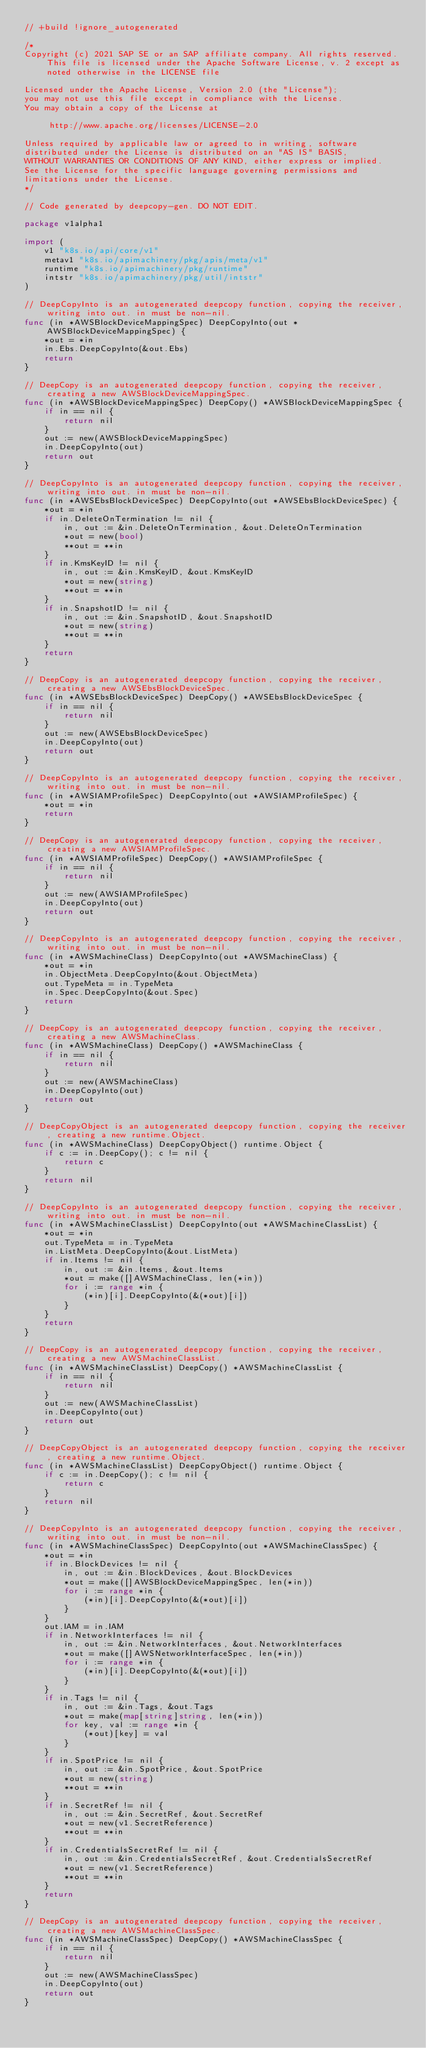<code> <loc_0><loc_0><loc_500><loc_500><_Go_>// +build !ignore_autogenerated

/*
Copyright (c) 2021 SAP SE or an SAP affiliate company. All rights reserved. This file is licensed under the Apache Software License, v. 2 except as noted otherwise in the LICENSE file

Licensed under the Apache License, Version 2.0 (the "License");
you may not use this file except in compliance with the License.
You may obtain a copy of the License at

     http://www.apache.org/licenses/LICENSE-2.0

Unless required by applicable law or agreed to in writing, software
distributed under the License is distributed on an "AS IS" BASIS,
WITHOUT WARRANTIES OR CONDITIONS OF ANY KIND, either express or implied.
See the License for the specific language governing permissions and
limitations under the License.
*/

// Code generated by deepcopy-gen. DO NOT EDIT.

package v1alpha1

import (
	v1 "k8s.io/api/core/v1"
	metav1 "k8s.io/apimachinery/pkg/apis/meta/v1"
	runtime "k8s.io/apimachinery/pkg/runtime"
	intstr "k8s.io/apimachinery/pkg/util/intstr"
)

// DeepCopyInto is an autogenerated deepcopy function, copying the receiver, writing into out. in must be non-nil.
func (in *AWSBlockDeviceMappingSpec) DeepCopyInto(out *AWSBlockDeviceMappingSpec) {
	*out = *in
	in.Ebs.DeepCopyInto(&out.Ebs)
	return
}

// DeepCopy is an autogenerated deepcopy function, copying the receiver, creating a new AWSBlockDeviceMappingSpec.
func (in *AWSBlockDeviceMappingSpec) DeepCopy() *AWSBlockDeviceMappingSpec {
	if in == nil {
		return nil
	}
	out := new(AWSBlockDeviceMappingSpec)
	in.DeepCopyInto(out)
	return out
}

// DeepCopyInto is an autogenerated deepcopy function, copying the receiver, writing into out. in must be non-nil.
func (in *AWSEbsBlockDeviceSpec) DeepCopyInto(out *AWSEbsBlockDeviceSpec) {
	*out = *in
	if in.DeleteOnTermination != nil {
		in, out := &in.DeleteOnTermination, &out.DeleteOnTermination
		*out = new(bool)
		**out = **in
	}
	if in.KmsKeyID != nil {
		in, out := &in.KmsKeyID, &out.KmsKeyID
		*out = new(string)
		**out = **in
	}
	if in.SnapshotID != nil {
		in, out := &in.SnapshotID, &out.SnapshotID
		*out = new(string)
		**out = **in
	}
	return
}

// DeepCopy is an autogenerated deepcopy function, copying the receiver, creating a new AWSEbsBlockDeviceSpec.
func (in *AWSEbsBlockDeviceSpec) DeepCopy() *AWSEbsBlockDeviceSpec {
	if in == nil {
		return nil
	}
	out := new(AWSEbsBlockDeviceSpec)
	in.DeepCopyInto(out)
	return out
}

// DeepCopyInto is an autogenerated deepcopy function, copying the receiver, writing into out. in must be non-nil.
func (in *AWSIAMProfileSpec) DeepCopyInto(out *AWSIAMProfileSpec) {
	*out = *in
	return
}

// DeepCopy is an autogenerated deepcopy function, copying the receiver, creating a new AWSIAMProfileSpec.
func (in *AWSIAMProfileSpec) DeepCopy() *AWSIAMProfileSpec {
	if in == nil {
		return nil
	}
	out := new(AWSIAMProfileSpec)
	in.DeepCopyInto(out)
	return out
}

// DeepCopyInto is an autogenerated deepcopy function, copying the receiver, writing into out. in must be non-nil.
func (in *AWSMachineClass) DeepCopyInto(out *AWSMachineClass) {
	*out = *in
	in.ObjectMeta.DeepCopyInto(&out.ObjectMeta)
	out.TypeMeta = in.TypeMeta
	in.Spec.DeepCopyInto(&out.Spec)
	return
}

// DeepCopy is an autogenerated deepcopy function, copying the receiver, creating a new AWSMachineClass.
func (in *AWSMachineClass) DeepCopy() *AWSMachineClass {
	if in == nil {
		return nil
	}
	out := new(AWSMachineClass)
	in.DeepCopyInto(out)
	return out
}

// DeepCopyObject is an autogenerated deepcopy function, copying the receiver, creating a new runtime.Object.
func (in *AWSMachineClass) DeepCopyObject() runtime.Object {
	if c := in.DeepCopy(); c != nil {
		return c
	}
	return nil
}

// DeepCopyInto is an autogenerated deepcopy function, copying the receiver, writing into out. in must be non-nil.
func (in *AWSMachineClassList) DeepCopyInto(out *AWSMachineClassList) {
	*out = *in
	out.TypeMeta = in.TypeMeta
	in.ListMeta.DeepCopyInto(&out.ListMeta)
	if in.Items != nil {
		in, out := &in.Items, &out.Items
		*out = make([]AWSMachineClass, len(*in))
		for i := range *in {
			(*in)[i].DeepCopyInto(&(*out)[i])
		}
	}
	return
}

// DeepCopy is an autogenerated deepcopy function, copying the receiver, creating a new AWSMachineClassList.
func (in *AWSMachineClassList) DeepCopy() *AWSMachineClassList {
	if in == nil {
		return nil
	}
	out := new(AWSMachineClassList)
	in.DeepCopyInto(out)
	return out
}

// DeepCopyObject is an autogenerated deepcopy function, copying the receiver, creating a new runtime.Object.
func (in *AWSMachineClassList) DeepCopyObject() runtime.Object {
	if c := in.DeepCopy(); c != nil {
		return c
	}
	return nil
}

// DeepCopyInto is an autogenerated deepcopy function, copying the receiver, writing into out. in must be non-nil.
func (in *AWSMachineClassSpec) DeepCopyInto(out *AWSMachineClassSpec) {
	*out = *in
	if in.BlockDevices != nil {
		in, out := &in.BlockDevices, &out.BlockDevices
		*out = make([]AWSBlockDeviceMappingSpec, len(*in))
		for i := range *in {
			(*in)[i].DeepCopyInto(&(*out)[i])
		}
	}
	out.IAM = in.IAM
	if in.NetworkInterfaces != nil {
		in, out := &in.NetworkInterfaces, &out.NetworkInterfaces
		*out = make([]AWSNetworkInterfaceSpec, len(*in))
		for i := range *in {
			(*in)[i].DeepCopyInto(&(*out)[i])
		}
	}
	if in.Tags != nil {
		in, out := &in.Tags, &out.Tags
		*out = make(map[string]string, len(*in))
		for key, val := range *in {
			(*out)[key] = val
		}
	}
	if in.SpotPrice != nil {
		in, out := &in.SpotPrice, &out.SpotPrice
		*out = new(string)
		**out = **in
	}
	if in.SecretRef != nil {
		in, out := &in.SecretRef, &out.SecretRef
		*out = new(v1.SecretReference)
		**out = **in
	}
	if in.CredentialsSecretRef != nil {
		in, out := &in.CredentialsSecretRef, &out.CredentialsSecretRef
		*out = new(v1.SecretReference)
		**out = **in
	}
	return
}

// DeepCopy is an autogenerated deepcopy function, copying the receiver, creating a new AWSMachineClassSpec.
func (in *AWSMachineClassSpec) DeepCopy() *AWSMachineClassSpec {
	if in == nil {
		return nil
	}
	out := new(AWSMachineClassSpec)
	in.DeepCopyInto(out)
	return out
}
</code> 